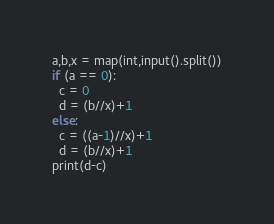<code> <loc_0><loc_0><loc_500><loc_500><_Python_>a,b,x = map(int,input().split())
if (a == 0):
  c = 0
  d = (b//x)+1
else:
  c = ((a-1)//x)+1
  d = (b//x)+1
print(d-c)</code> 